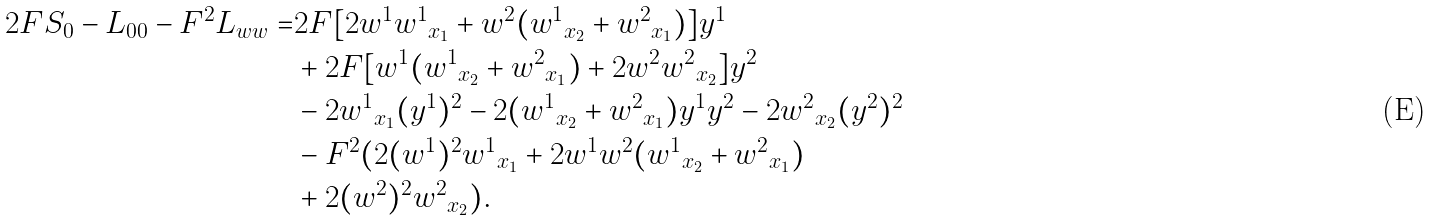Convert formula to latex. <formula><loc_0><loc_0><loc_500><loc_500>2 F S _ { 0 } - L _ { 0 0 } - F ^ { 2 } L _ { w w } = & 2 F [ 2 w ^ { 1 } { w ^ { 1 } } _ { x _ { 1 } } + w ^ { 2 } ( { w ^ { 1 } } _ { x _ { 2 } } + { w ^ { 2 } } _ { x _ { 1 } } ) ] y ^ { 1 } \\ & + 2 F [ w ^ { 1 } ( { w ^ { 1 } } _ { x _ { 2 } } + { w ^ { 2 } } _ { x _ { 1 } } ) + 2 w ^ { 2 } { w ^ { 2 } } _ { x _ { 2 } } ] y ^ { 2 } \\ & - 2 { w ^ { 1 } } _ { x _ { 1 } } ( y ^ { 1 } ) ^ { 2 } - 2 ( { w ^ { 1 } } _ { x _ { 2 } } + { w ^ { 2 } } _ { x _ { 1 } } ) y ^ { 1 } y ^ { 2 } - 2 { w ^ { 2 } } _ { x _ { 2 } } ( y ^ { 2 } ) ^ { 2 } \\ & - F ^ { 2 } ( 2 ( w ^ { 1 } ) ^ { 2 } { w ^ { 1 } } _ { x _ { 1 } } + 2 w ^ { 1 } w ^ { 2 } ( { w ^ { 1 } } _ { x _ { 2 } } + { w ^ { 2 } } _ { x _ { 1 } } ) \\ & + 2 ( w ^ { 2 } ) ^ { 2 } { w ^ { 2 } } _ { x _ { 2 } } ) .</formula> 